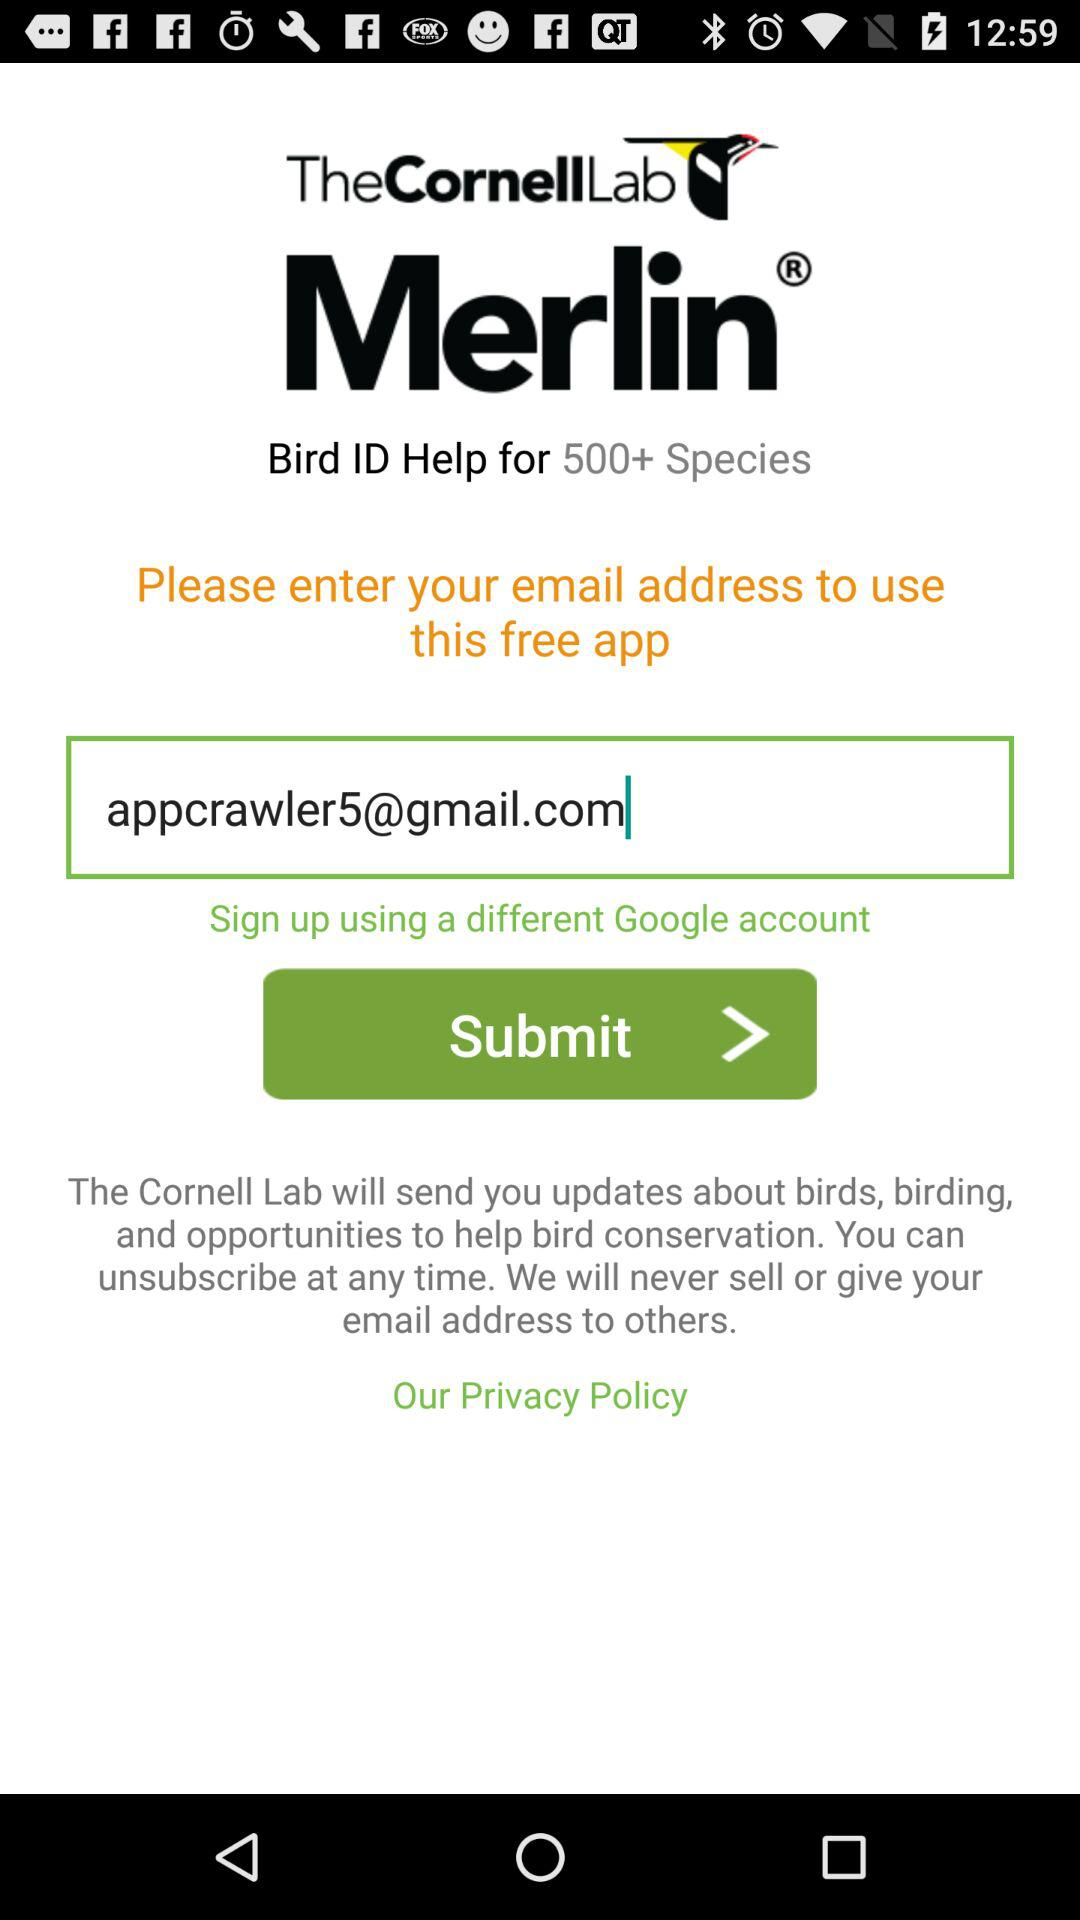What is the email address? The email address is appcrawler5@gmail.com. 